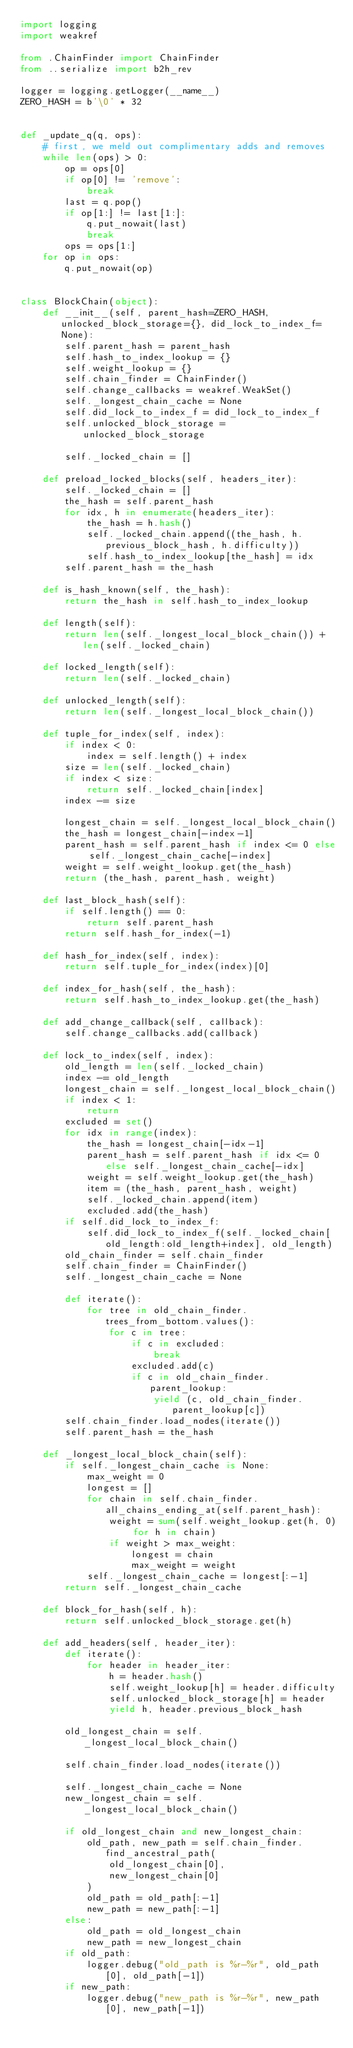<code> <loc_0><loc_0><loc_500><loc_500><_Python_>import logging
import weakref

from .ChainFinder import ChainFinder
from ..serialize import b2h_rev

logger = logging.getLogger(__name__)
ZERO_HASH = b'\0' * 32


def _update_q(q, ops):
    # first, we meld out complimentary adds and removes
    while len(ops) > 0:
        op = ops[0]
        if op[0] != 'remove':
            break
        last = q.pop()
        if op[1:] != last[1:]:
            q.put_nowait(last)
            break
        ops = ops[1:]
    for op in ops:
        q.put_nowait(op)


class BlockChain(object):
    def __init__(self, parent_hash=ZERO_HASH, unlocked_block_storage={}, did_lock_to_index_f=None):
        self.parent_hash = parent_hash
        self.hash_to_index_lookup = {}
        self.weight_lookup = {}
        self.chain_finder = ChainFinder()
        self.change_callbacks = weakref.WeakSet()
        self._longest_chain_cache = None
        self.did_lock_to_index_f = did_lock_to_index_f
        self.unlocked_block_storage = unlocked_block_storage

        self._locked_chain = []

    def preload_locked_blocks(self, headers_iter):
        self._locked_chain = []
        the_hash = self.parent_hash
        for idx, h in enumerate(headers_iter):
            the_hash = h.hash()
            self._locked_chain.append((the_hash, h.previous_block_hash, h.difficulty))
            self.hash_to_index_lookup[the_hash] = idx
        self.parent_hash = the_hash

    def is_hash_known(self, the_hash):
        return the_hash in self.hash_to_index_lookup

    def length(self):
        return len(self._longest_local_block_chain()) + len(self._locked_chain)

    def locked_length(self):
        return len(self._locked_chain)

    def unlocked_length(self):
        return len(self._longest_local_block_chain())

    def tuple_for_index(self, index):
        if index < 0:
            index = self.length() + index
        size = len(self._locked_chain)
        if index < size:
            return self._locked_chain[index]
        index -= size

        longest_chain = self._longest_local_block_chain()
        the_hash = longest_chain[-index-1]
        parent_hash = self.parent_hash if index <= 0 else self._longest_chain_cache[-index]
        weight = self.weight_lookup.get(the_hash)
        return (the_hash, parent_hash, weight)

    def last_block_hash(self):
        if self.length() == 0:
            return self.parent_hash
        return self.hash_for_index(-1)

    def hash_for_index(self, index):
        return self.tuple_for_index(index)[0]

    def index_for_hash(self, the_hash):
        return self.hash_to_index_lookup.get(the_hash)

    def add_change_callback(self, callback):
        self.change_callbacks.add(callback)

    def lock_to_index(self, index):
        old_length = len(self._locked_chain)
        index -= old_length
        longest_chain = self._longest_local_block_chain()
        if index < 1:
            return
        excluded = set()
        for idx in range(index):
            the_hash = longest_chain[-idx-1]
            parent_hash = self.parent_hash if idx <= 0 else self._longest_chain_cache[-idx]
            weight = self.weight_lookup.get(the_hash)
            item = (the_hash, parent_hash, weight)
            self._locked_chain.append(item)
            excluded.add(the_hash)
        if self.did_lock_to_index_f:
            self.did_lock_to_index_f(self._locked_chain[old_length:old_length+index], old_length)
        old_chain_finder = self.chain_finder
        self.chain_finder = ChainFinder()
        self._longest_chain_cache = None

        def iterate():
            for tree in old_chain_finder.trees_from_bottom.values():
                for c in tree:
                    if c in excluded:
                        break
                    excluded.add(c)
                    if c in old_chain_finder.parent_lookup:
                        yield (c, old_chain_finder.parent_lookup[c])
        self.chain_finder.load_nodes(iterate())
        self.parent_hash = the_hash

    def _longest_local_block_chain(self):
        if self._longest_chain_cache is None:
            max_weight = 0
            longest = []
            for chain in self.chain_finder.all_chains_ending_at(self.parent_hash):
                weight = sum(self.weight_lookup.get(h, 0) for h in chain)
                if weight > max_weight:
                    longest = chain
                    max_weight = weight
            self._longest_chain_cache = longest[:-1]
        return self._longest_chain_cache

    def block_for_hash(self, h):
        return self.unlocked_block_storage.get(h)

    def add_headers(self, header_iter):
        def iterate():
            for header in header_iter:
                h = header.hash()
                self.weight_lookup[h] = header.difficulty
                self.unlocked_block_storage[h] = header
                yield h, header.previous_block_hash

        old_longest_chain = self._longest_local_block_chain()

        self.chain_finder.load_nodes(iterate())

        self._longest_chain_cache = None
        new_longest_chain = self._longest_local_block_chain()

        if old_longest_chain and new_longest_chain:
            old_path, new_path = self.chain_finder.find_ancestral_path(
                old_longest_chain[0],
                new_longest_chain[0]
            )
            old_path = old_path[:-1]
            new_path = new_path[:-1]
        else:
            old_path = old_longest_chain
            new_path = new_longest_chain
        if old_path:
            logger.debug("old_path is %r-%r", old_path[0], old_path[-1])
        if new_path:
            logger.debug("new_path is %r-%r", new_path[0], new_path[-1])</code> 